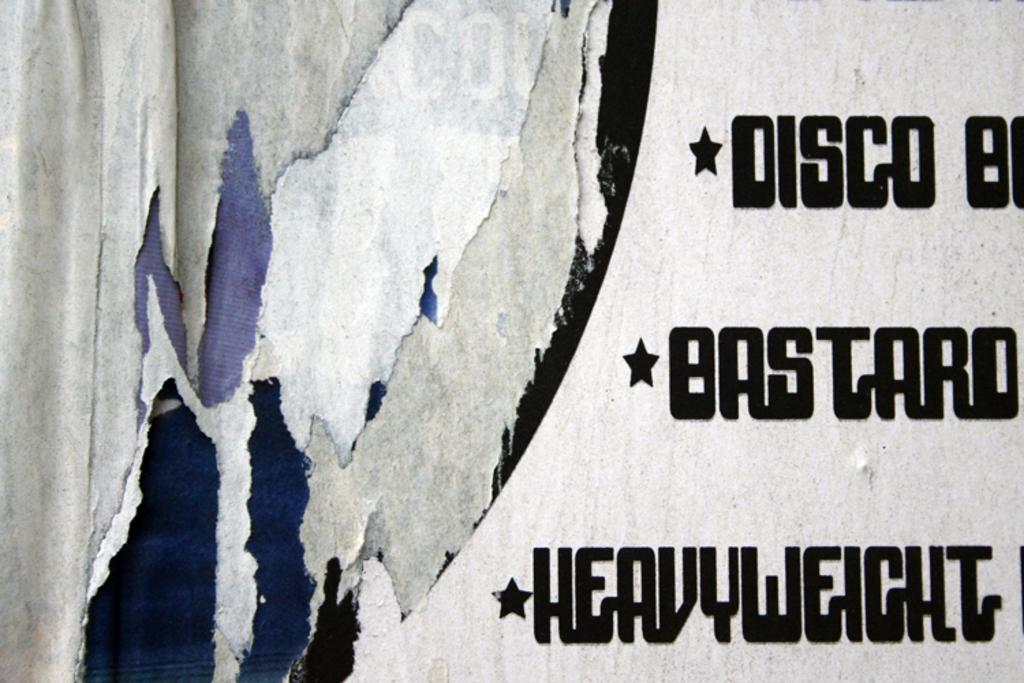<image>
Write a terse but informative summary of the picture. a gray and black background wit the word disco in front 